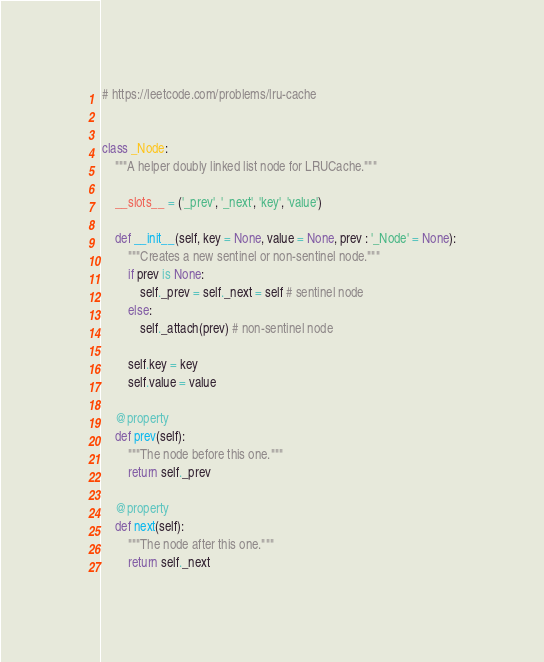<code> <loc_0><loc_0><loc_500><loc_500><_Python_># https://leetcode.com/problems/lru-cache


class _Node:
    """A helper doubly linked list node for LRUCache."""

    __slots__ = ('_prev', '_next', 'key', 'value')

    def __init__(self, key = None, value = None, prev : '_Node' = None):
        """Creates a new sentinel or non-sentinel node."""
        if prev is None:
            self._prev = self._next = self # sentinel node
        else:
            self._attach(prev) # non-sentinel node

        self.key = key
        self.value = value

    @property
    def prev(self):
        """The node before this one."""
        return self._prev

    @property
    def next(self):
        """The node after this one."""
        return self._next
</code> 